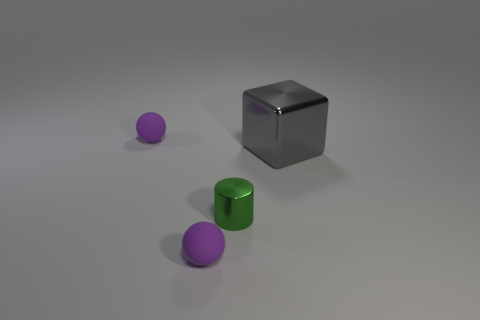Subtract 1 cubes. How many cubes are left? 0 Add 1 spheres. How many objects exist? 5 Subtract all brown cylinders. Subtract all cyan balls. How many cylinders are left? 1 Add 4 purple things. How many purple things exist? 6 Subtract 0 blue balls. How many objects are left? 4 Subtract all cylinders. How many objects are left? 3 Subtract all gray matte cylinders. Subtract all gray things. How many objects are left? 3 Add 3 small purple spheres. How many small purple spheres are left? 5 